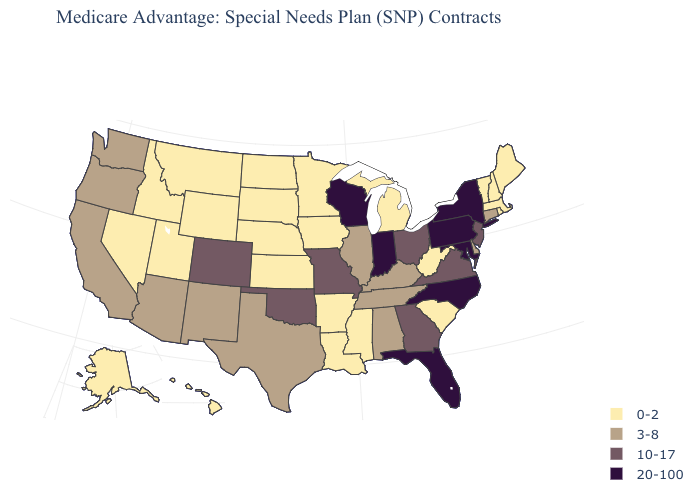Which states have the lowest value in the West?
Be succinct. Alaska, Hawaii, Idaho, Montana, Nevada, Utah, Wyoming. Does the map have missing data?
Give a very brief answer. No. Among the states that border North Dakota , which have the highest value?
Answer briefly. Minnesota, Montana, South Dakota. What is the highest value in the MidWest ?
Quick response, please. 20-100. Name the states that have a value in the range 10-17?
Keep it brief. Colorado, Georgia, Missouri, New Jersey, Ohio, Oklahoma, Virginia. What is the lowest value in the USA?
Answer briefly. 0-2. What is the value of New Hampshire?
Be succinct. 0-2. Is the legend a continuous bar?
Write a very short answer. No. Among the states that border Minnesota , does Wisconsin have the lowest value?
Short answer required. No. Among the states that border Michigan , which have the lowest value?
Give a very brief answer. Ohio. Name the states that have a value in the range 0-2?
Keep it brief. Alaska, Arkansas, Hawaii, Iowa, Idaho, Kansas, Louisiana, Massachusetts, Maine, Michigan, Minnesota, Mississippi, Montana, North Dakota, Nebraska, New Hampshire, Nevada, Rhode Island, South Carolina, South Dakota, Utah, Vermont, West Virginia, Wyoming. Name the states that have a value in the range 0-2?
Give a very brief answer. Alaska, Arkansas, Hawaii, Iowa, Idaho, Kansas, Louisiana, Massachusetts, Maine, Michigan, Minnesota, Mississippi, Montana, North Dakota, Nebraska, New Hampshire, Nevada, Rhode Island, South Carolina, South Dakota, Utah, Vermont, West Virginia, Wyoming. Name the states that have a value in the range 10-17?
Write a very short answer. Colorado, Georgia, Missouri, New Jersey, Ohio, Oklahoma, Virginia. Does Rhode Island have the same value as Maine?
Answer briefly. Yes. 